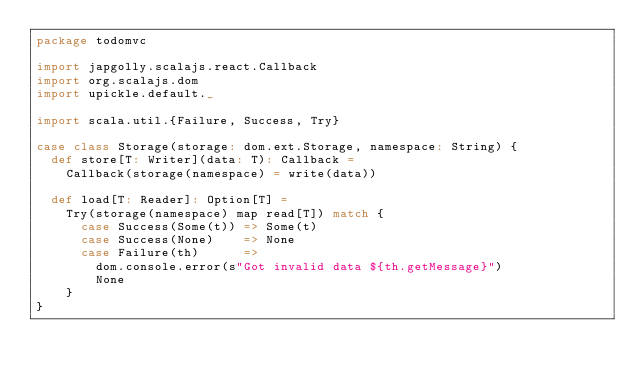<code> <loc_0><loc_0><loc_500><loc_500><_Scala_>package todomvc

import japgolly.scalajs.react.Callback
import org.scalajs.dom
import upickle.default._

import scala.util.{Failure, Success, Try}

case class Storage(storage: dom.ext.Storage, namespace: String) {
  def store[T: Writer](data: T): Callback =
    Callback(storage(namespace) = write(data))

  def load[T: Reader]: Option[T] =
    Try(storage(namespace) map read[T]) match {
      case Success(Some(t)) => Some(t)
      case Success(None)    => None
      case Failure(th)      =>
        dom.console.error(s"Got invalid data ${th.getMessage}")
        None
    }
}
</code> 